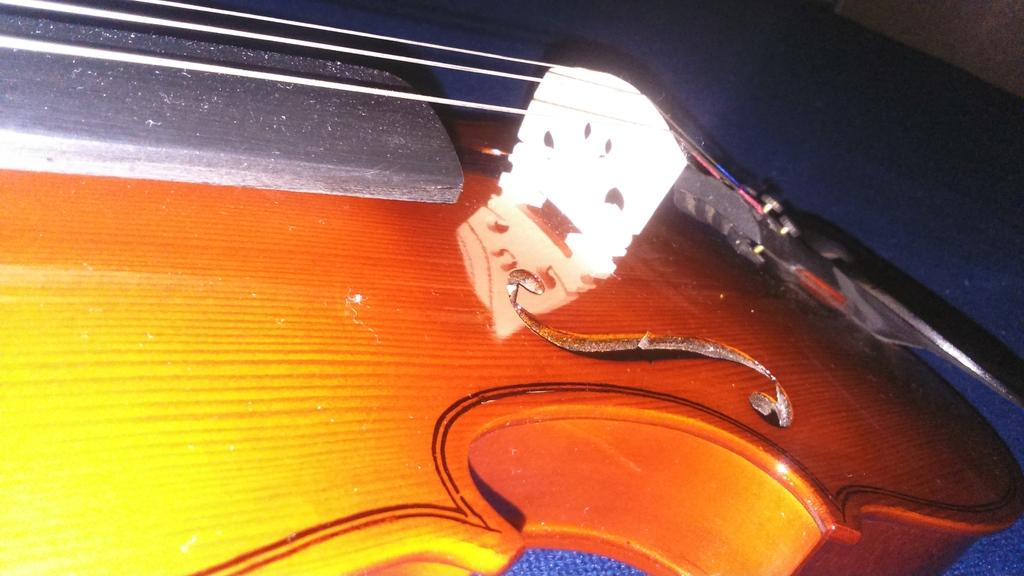What type of object can be seen in the image? There is a musical instrument in the image. What type of health test is being conducted on the musical instrument in the image? There is no health test being conducted on the musical instrument in the image, as the provided fact does not mention any health-related context. 